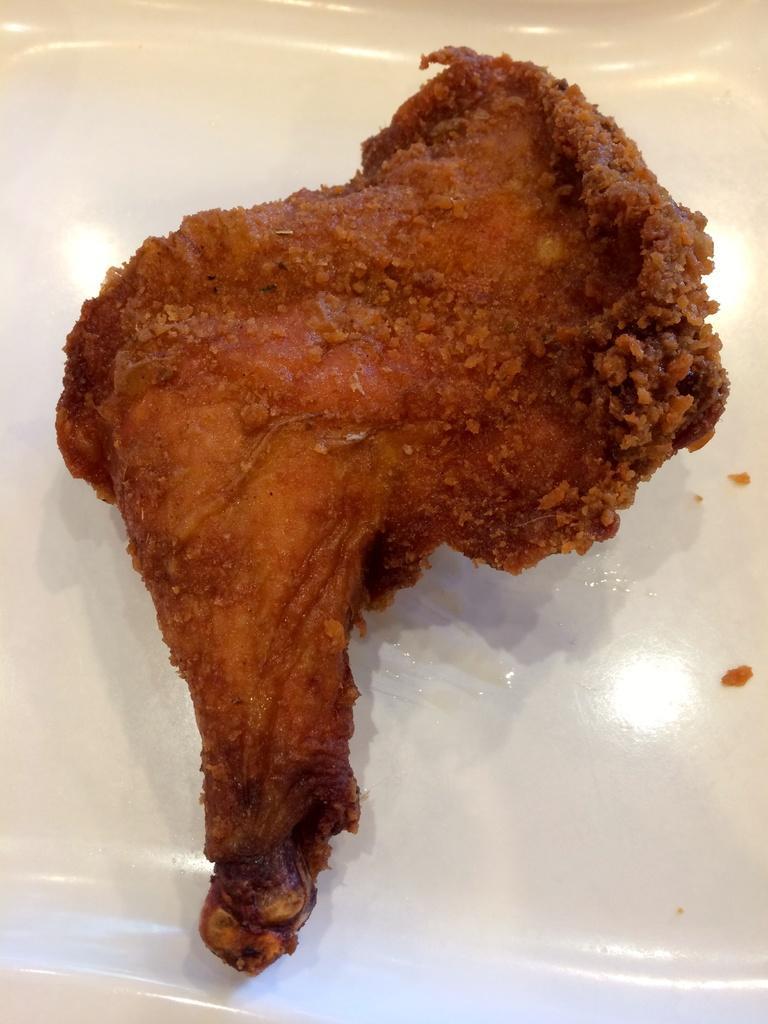Can you describe this image briefly? As we can see in the image there is a white color plate. On plate there is chicken peace. 